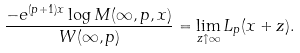<formula> <loc_0><loc_0><loc_500><loc_500>\frac { - e ^ { ( p + 1 ) x } \log M ( \infty , p , x ) } { W ( \infty , p ) } = \lim _ { z \uparrow \infty } L _ { p } ( x + z ) .</formula> 